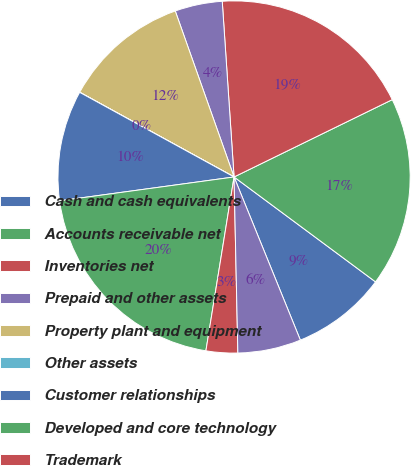Convert chart. <chart><loc_0><loc_0><loc_500><loc_500><pie_chart><fcel>Cash and cash equivalents<fcel>Accounts receivable net<fcel>Inventories net<fcel>Prepaid and other assets<fcel>Property plant and equipment<fcel>Other assets<fcel>Customer relationships<fcel>Developed and core technology<fcel>Trademark<fcel>Internal use software<nl><fcel>8.7%<fcel>17.39%<fcel>18.83%<fcel>4.35%<fcel>11.59%<fcel>0.01%<fcel>10.14%<fcel>20.28%<fcel>2.9%<fcel>5.8%<nl></chart> 